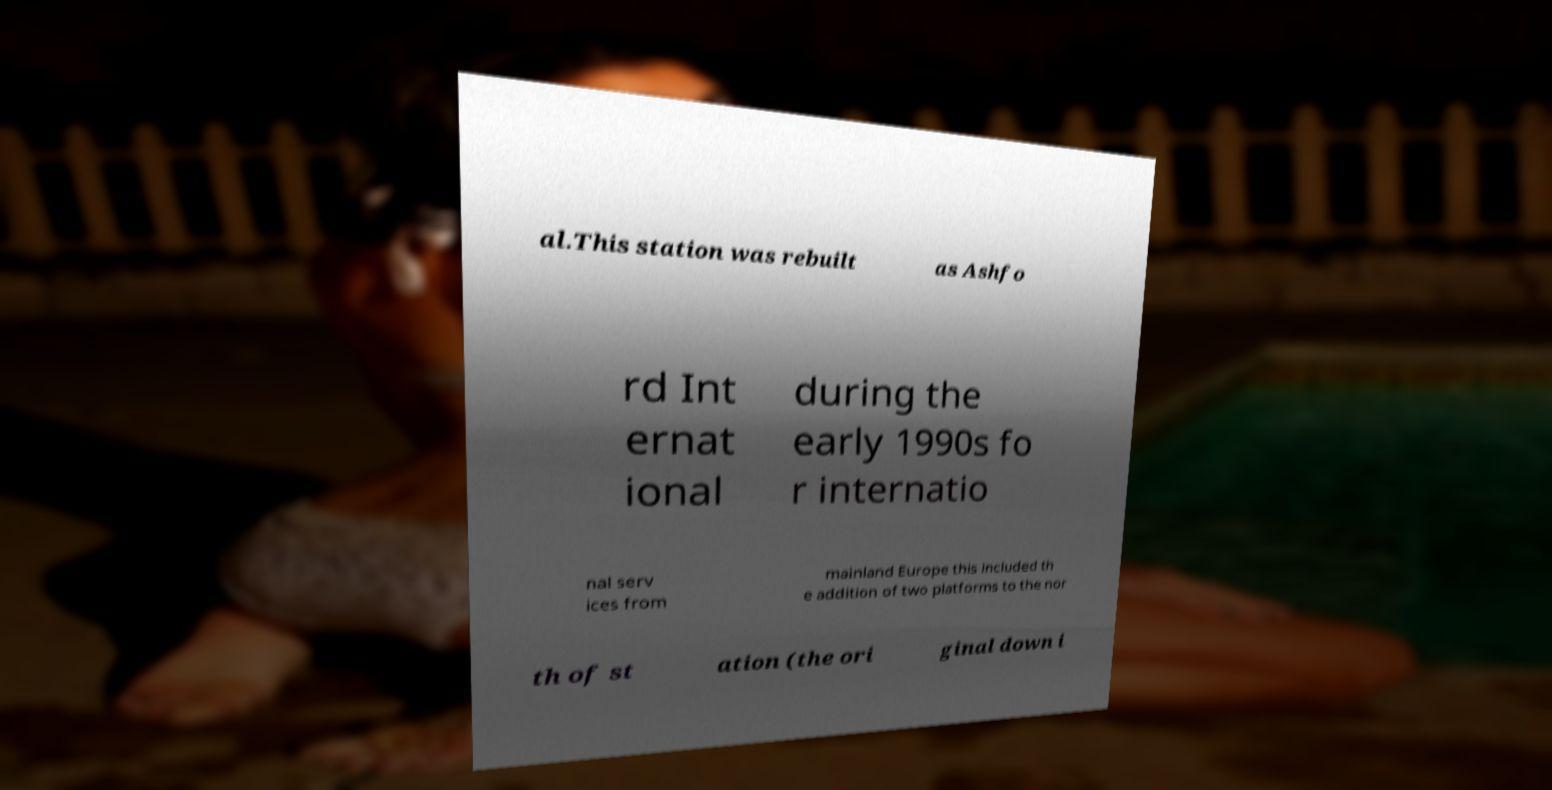Please identify and transcribe the text found in this image. al.This station was rebuilt as Ashfo rd Int ernat ional during the early 1990s fo r internatio nal serv ices from mainland Europe this included th e addition of two platforms to the nor th of st ation (the ori ginal down i 